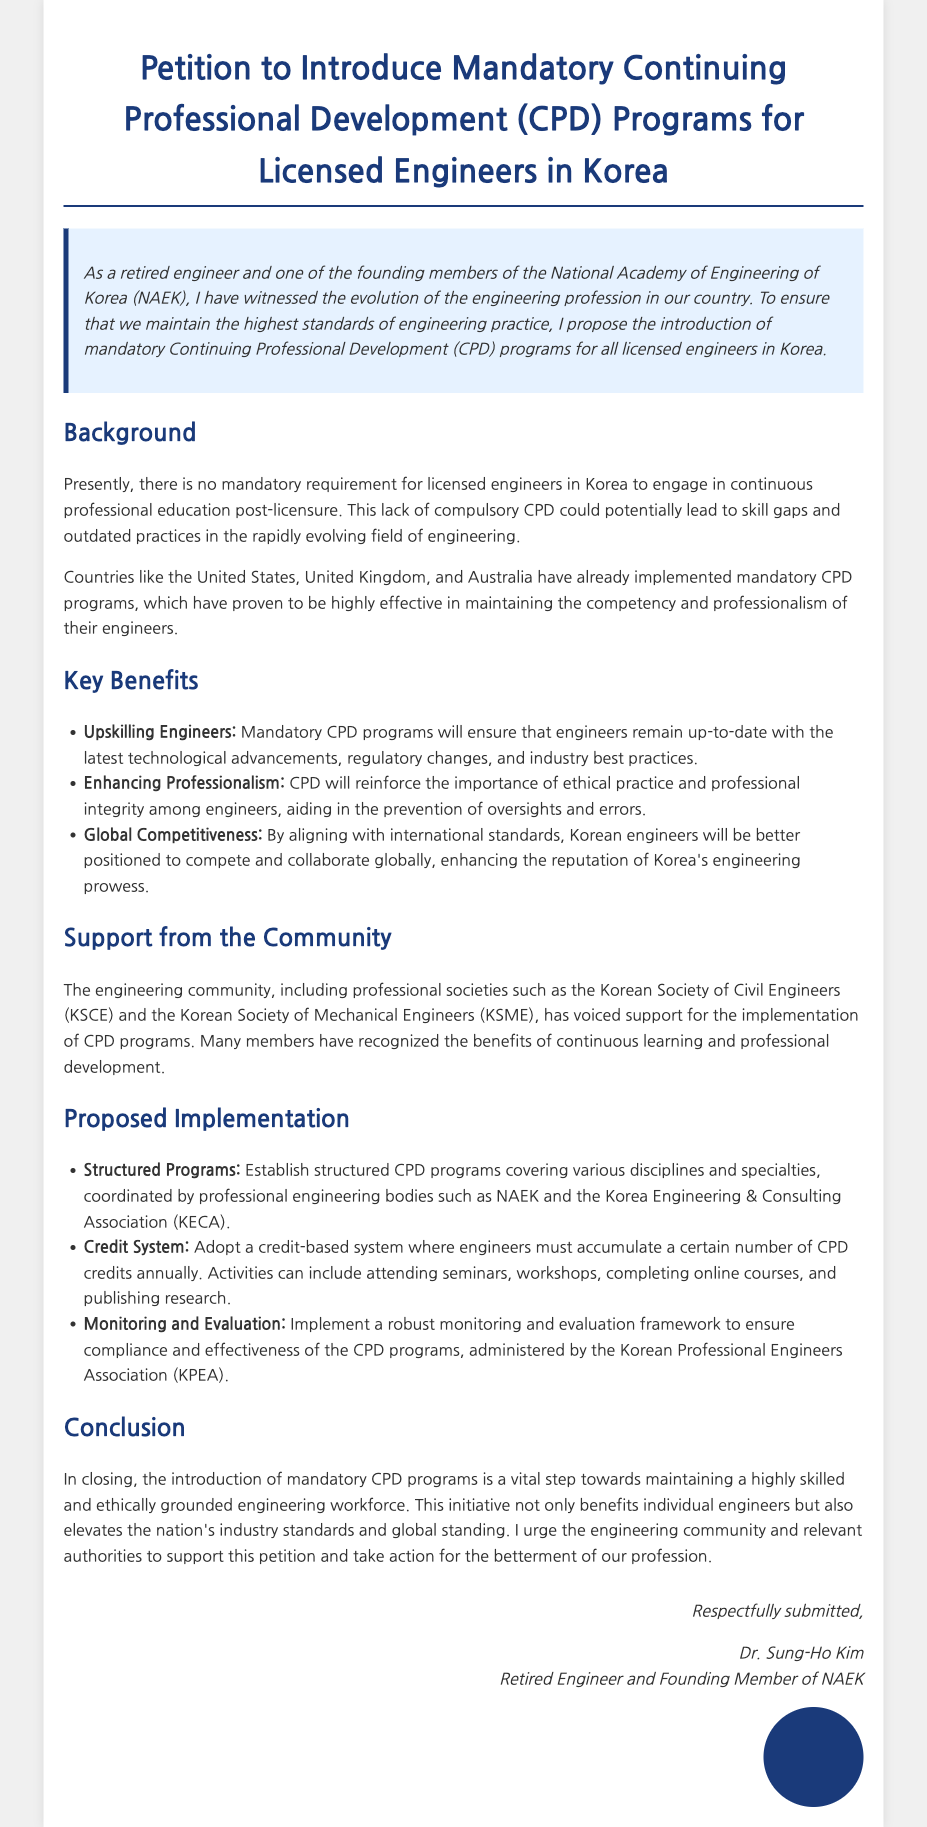What is the title of the petition? The title of the petition is provided at the top of the document.
Answer: Petition to Introduce Mandatory Continuing Professional Development (CPD) Programs for Licensed Engineers in Korea Who is the author of the petition? The author of the petition is mentioned in the signature section at the bottom of the document.
Answer: Dr. Sung-Ho Kim What is one of the key benefits of CPD mentioned? The document lists several benefits of CPD, one of which is highlighted in the key benefits section.
Answer: Upskilling Engineers Which professional society supports the implementation of CPD programs? The document mentions support from various professional societies in the community section.
Answer: Korean Society of Civil Engineers (KSCE) What does CPD stand for? The full form of CPD is stated in the title of the petition.
Answer: Continuing Professional Development What type of system is proposed for CPD? The document outlines a specific approach to structuring CPD programs in the proposed implementation section.
Answer: Credit-based system How many areas of CPD activities does the document suggest? The proposed implementation section refers to several types of CPD activities.
Answer: Four (including seminars, workshops, online courses, and research) What is the main aim of introducing CPD programs? The conclusion summarizes the overarching goal of the CPD initiative.
Answer: Maintaining a highly skilled and ethically grounded engineering workforce 